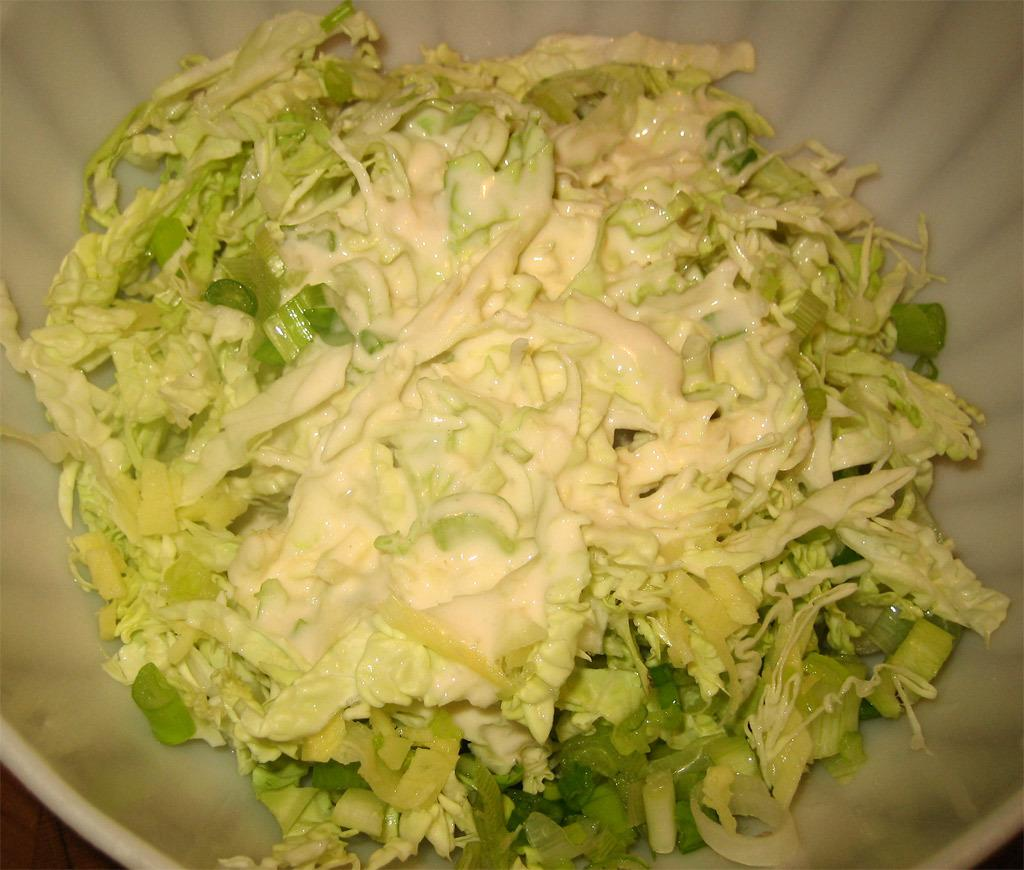What is in the bowl that is visible in the image? There is food in a bowl in the image. Where is the bowl located in the image? The bowl is placed on a surface in the image. What type of sand can be seen on the moon in the image? There is no sand or moon present in the image; it only features a bowl of food placed on a surface. 